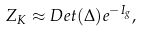<formula> <loc_0><loc_0><loc_500><loc_500>Z _ { K } \approx D e t ( \Delta ) e ^ { - I _ { g } } ,</formula> 